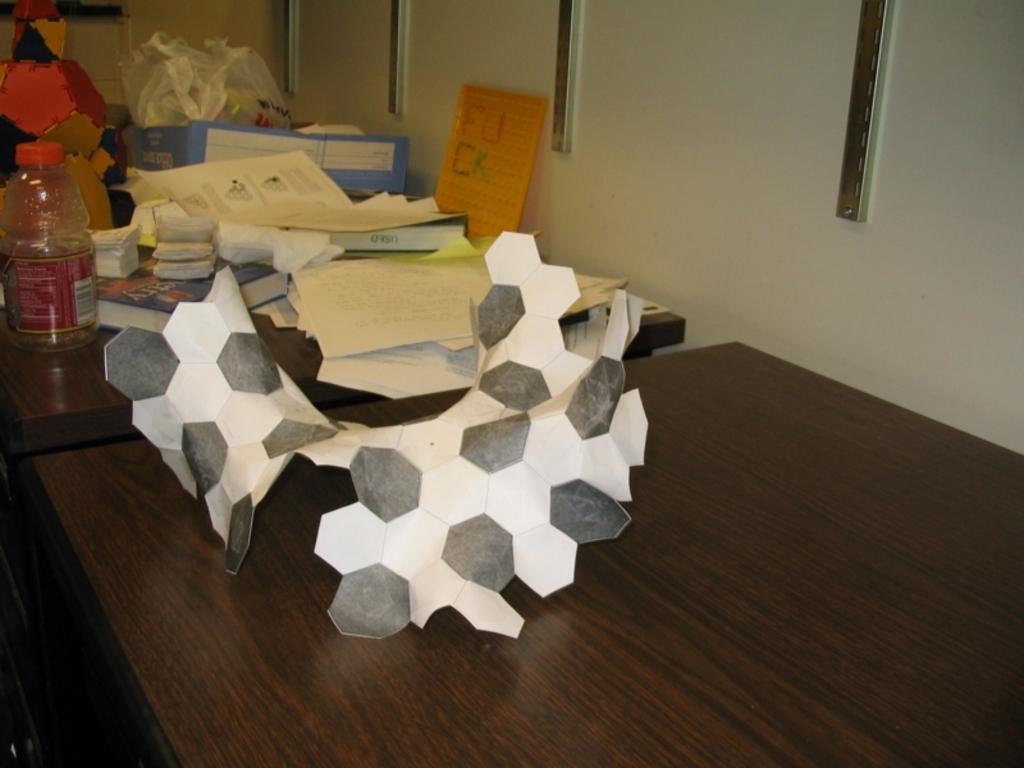Could you give a brief overview of what you see in this image? In this image, we can see some tables with objects like a bottle, posters and some books. We can also see some craft. We can see the wall with some metal objects. 